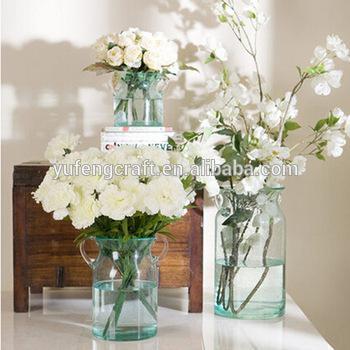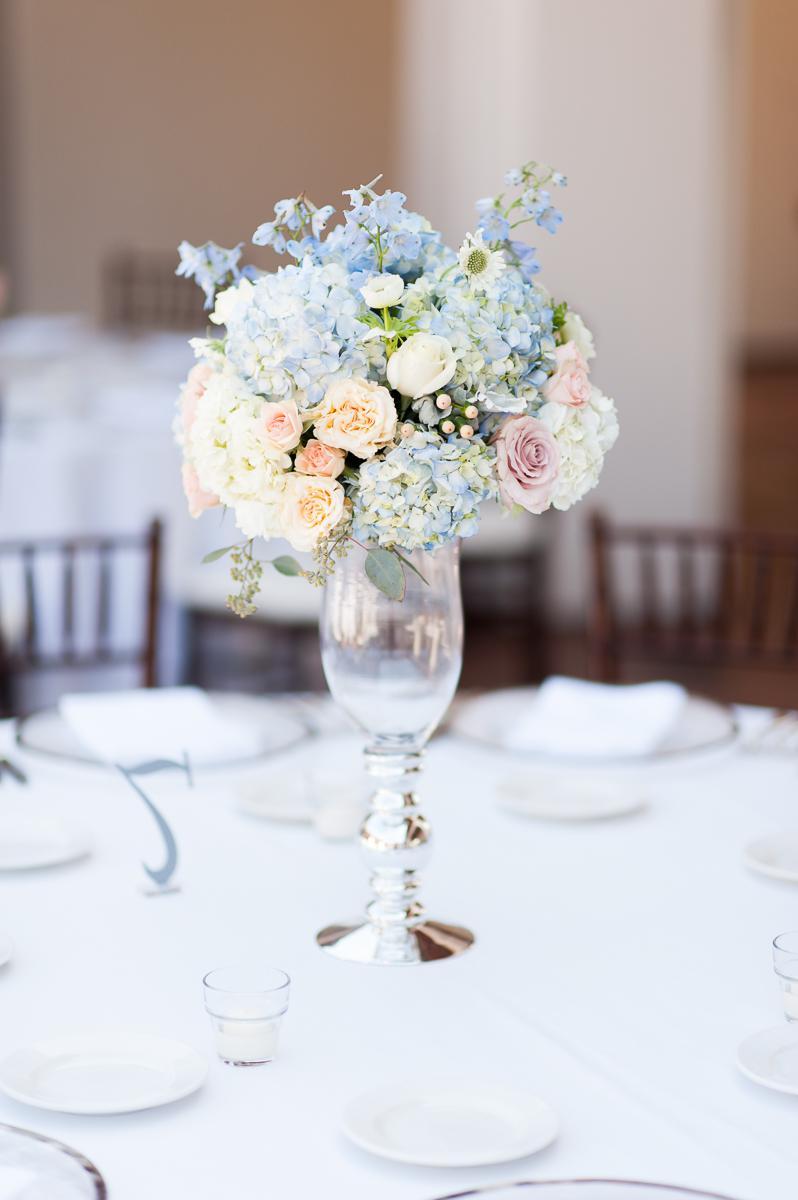The first image is the image on the left, the second image is the image on the right. Considering the images on both sides, is "The vases in the left image are silver colored." valid? Answer yes or no. No. The first image is the image on the left, the second image is the image on the right. Given the left and right images, does the statement "Two clear vases with green fruit in their water-filled bases are shown in the right image." hold true? Answer yes or no. No. 